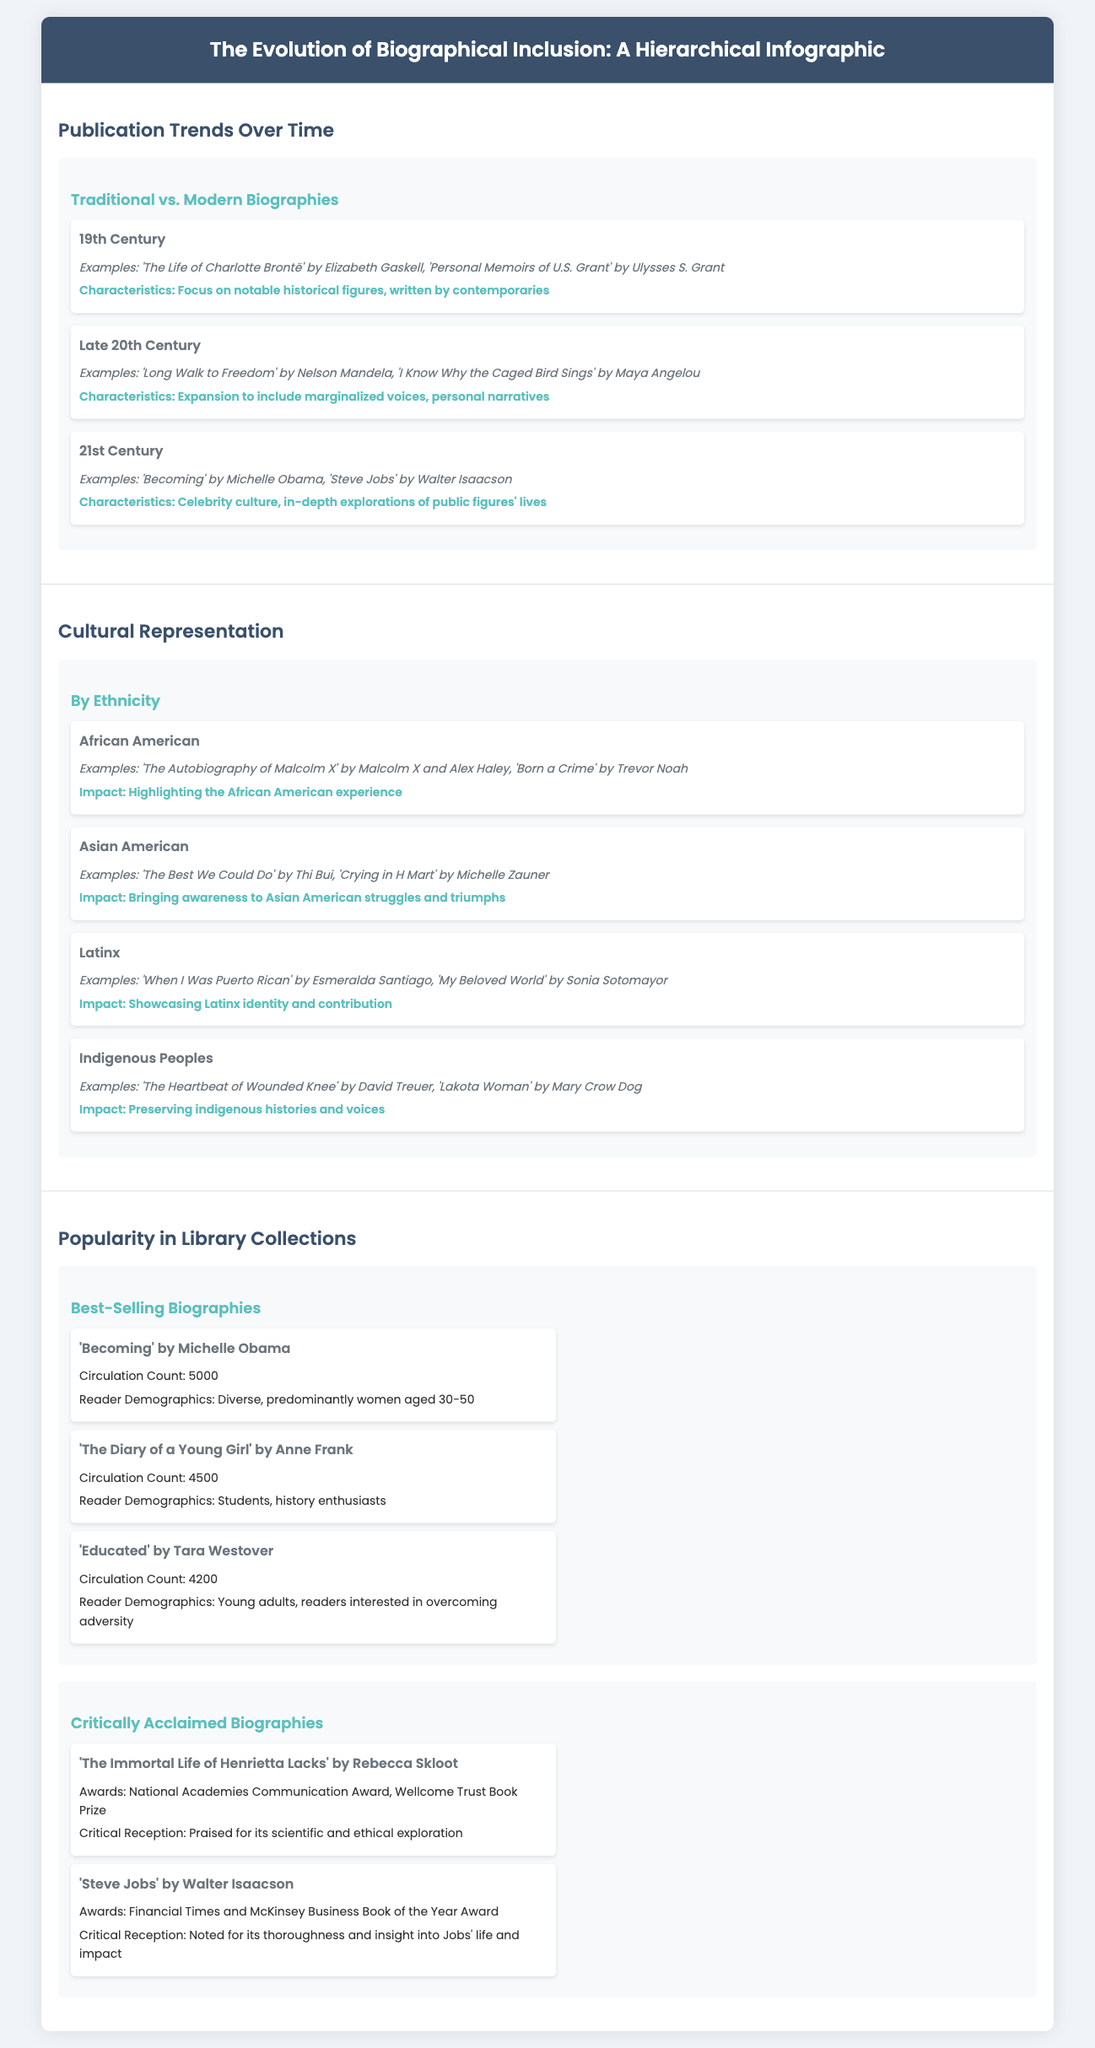What are the characteristics of 19th-century biographies? The 19th-century biographies focus on notable historical figures and are written by contemporaries.
Answer: Focus on notable historical figures, written by contemporaries What is an example of a Latinx biography? A Latinx biography mentioned in the document is 'When I Was Puerto Rican' by Esmeralda Santiago.
Answer: 'When I Was Puerto Rican' by Esmeralda Santiago How many circulations does 'Becoming' by Michelle Obama have? The document states that 'Becoming' has a circulation count of 5000.
Answer: 5000 Which demographic primarily reads 'Educated' by Tara Westover? The document indicates that 'Educated' is primarily read by young adults and readers interested in overcoming adversity.
Answer: Young adults, readers interested in overcoming adversity What is the impact of Asian American biographies? The impact of Asian American biographies is bringing awareness to Asian American struggles and triumphs.
Answer: Bringing awareness to Asian American struggles and triumphs What award did 'The Immortal Life of Henrietta Lacks' win? The document lists that 'The Immortal Life of Henrietta Lacks' received the National Academies Communication Award.
Answer: National Academies Communication Award What are the common characteristics of 21st-century biographies? The characteristics of 21st-century biographies include celebrity culture and in-depth explorations of public figures' lives.
Answer: Celebrity culture, in-depth explorations of public figures' lives How many critically acclaimed biographies are listed? The document includes two critically acclaimed biographies.
Answer: Two What does the hierarchy of the infographic represent? The hierarchy of the infographic represents the evolution of biographical inclusion across different dimensions such as publication trends and cultural representation.
Answer: Evolution of biographical inclusion 